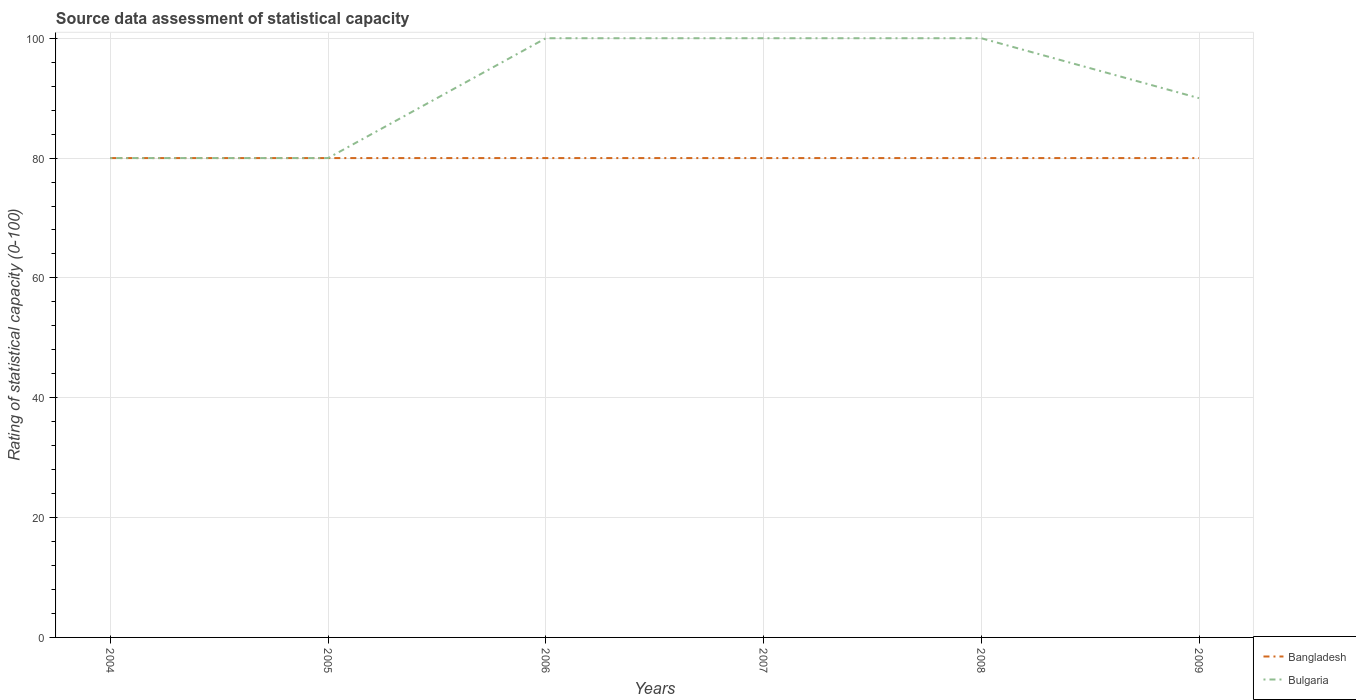Does the line corresponding to Bulgaria intersect with the line corresponding to Bangladesh?
Keep it short and to the point. Yes. Is the number of lines equal to the number of legend labels?
Provide a short and direct response. Yes. Across all years, what is the maximum rating of statistical capacity in Bangladesh?
Offer a very short reply. 80. What is the total rating of statistical capacity in Bangladesh in the graph?
Ensure brevity in your answer.  0. What is the difference between the highest and the lowest rating of statistical capacity in Bangladesh?
Provide a succinct answer. 0. Is the rating of statistical capacity in Bulgaria strictly greater than the rating of statistical capacity in Bangladesh over the years?
Your answer should be very brief. No. How many lines are there?
Offer a very short reply. 2. Does the graph contain grids?
Give a very brief answer. Yes. How are the legend labels stacked?
Keep it short and to the point. Vertical. What is the title of the graph?
Offer a terse response. Source data assessment of statistical capacity. Does "Saudi Arabia" appear as one of the legend labels in the graph?
Your response must be concise. No. What is the label or title of the X-axis?
Your response must be concise. Years. What is the label or title of the Y-axis?
Keep it short and to the point. Rating of statistical capacity (0-100). What is the Rating of statistical capacity (0-100) of Bangladesh in 2004?
Offer a very short reply. 80. What is the Rating of statistical capacity (0-100) of Bulgaria in 2005?
Provide a succinct answer. 80. What is the Rating of statistical capacity (0-100) of Bangladesh in 2006?
Offer a very short reply. 80. What is the Rating of statistical capacity (0-100) in Bulgaria in 2006?
Offer a very short reply. 100. What is the Rating of statistical capacity (0-100) in Bulgaria in 2007?
Provide a succinct answer. 100. What is the Rating of statistical capacity (0-100) of Bulgaria in 2008?
Provide a succinct answer. 100. What is the Rating of statistical capacity (0-100) of Bangladesh in 2009?
Provide a short and direct response. 80. Across all years, what is the maximum Rating of statistical capacity (0-100) in Bulgaria?
Offer a very short reply. 100. What is the total Rating of statistical capacity (0-100) in Bangladesh in the graph?
Your answer should be very brief. 480. What is the total Rating of statistical capacity (0-100) of Bulgaria in the graph?
Your answer should be very brief. 550. What is the difference between the Rating of statistical capacity (0-100) of Bulgaria in 2004 and that in 2007?
Offer a very short reply. -20. What is the difference between the Rating of statistical capacity (0-100) in Bangladesh in 2004 and that in 2008?
Offer a very short reply. 0. What is the difference between the Rating of statistical capacity (0-100) in Bulgaria in 2004 and that in 2008?
Provide a succinct answer. -20. What is the difference between the Rating of statistical capacity (0-100) in Bangladesh in 2004 and that in 2009?
Your answer should be very brief. 0. What is the difference between the Rating of statistical capacity (0-100) of Bulgaria in 2004 and that in 2009?
Provide a succinct answer. -10. What is the difference between the Rating of statistical capacity (0-100) in Bangladesh in 2005 and that in 2006?
Ensure brevity in your answer.  0. What is the difference between the Rating of statistical capacity (0-100) of Bulgaria in 2005 and that in 2006?
Offer a very short reply. -20. What is the difference between the Rating of statistical capacity (0-100) in Bangladesh in 2005 and that in 2007?
Your answer should be compact. 0. What is the difference between the Rating of statistical capacity (0-100) of Bulgaria in 2005 and that in 2007?
Ensure brevity in your answer.  -20. What is the difference between the Rating of statistical capacity (0-100) of Bangladesh in 2005 and that in 2008?
Your answer should be compact. 0. What is the difference between the Rating of statistical capacity (0-100) in Bangladesh in 2005 and that in 2009?
Make the answer very short. 0. What is the difference between the Rating of statistical capacity (0-100) in Bulgaria in 2006 and that in 2007?
Make the answer very short. 0. What is the difference between the Rating of statistical capacity (0-100) in Bulgaria in 2006 and that in 2008?
Give a very brief answer. 0. What is the difference between the Rating of statistical capacity (0-100) in Bulgaria in 2007 and that in 2008?
Give a very brief answer. 0. What is the difference between the Rating of statistical capacity (0-100) of Bulgaria in 2007 and that in 2009?
Offer a terse response. 10. What is the difference between the Rating of statistical capacity (0-100) in Bangladesh in 2008 and that in 2009?
Offer a terse response. 0. What is the difference between the Rating of statistical capacity (0-100) in Bulgaria in 2008 and that in 2009?
Keep it short and to the point. 10. What is the difference between the Rating of statistical capacity (0-100) in Bangladesh in 2004 and the Rating of statistical capacity (0-100) in Bulgaria in 2005?
Your answer should be very brief. 0. What is the difference between the Rating of statistical capacity (0-100) of Bangladesh in 2004 and the Rating of statistical capacity (0-100) of Bulgaria in 2008?
Make the answer very short. -20. What is the difference between the Rating of statistical capacity (0-100) in Bangladesh in 2005 and the Rating of statistical capacity (0-100) in Bulgaria in 2007?
Keep it short and to the point. -20. What is the difference between the Rating of statistical capacity (0-100) of Bangladesh in 2005 and the Rating of statistical capacity (0-100) of Bulgaria in 2008?
Offer a very short reply. -20. What is the difference between the Rating of statistical capacity (0-100) in Bangladesh in 2006 and the Rating of statistical capacity (0-100) in Bulgaria in 2007?
Your response must be concise. -20. What is the difference between the Rating of statistical capacity (0-100) in Bangladesh in 2006 and the Rating of statistical capacity (0-100) in Bulgaria in 2008?
Your answer should be compact. -20. What is the difference between the Rating of statistical capacity (0-100) of Bangladesh in 2006 and the Rating of statistical capacity (0-100) of Bulgaria in 2009?
Provide a short and direct response. -10. What is the difference between the Rating of statistical capacity (0-100) of Bangladesh in 2007 and the Rating of statistical capacity (0-100) of Bulgaria in 2009?
Make the answer very short. -10. What is the average Rating of statistical capacity (0-100) in Bulgaria per year?
Ensure brevity in your answer.  91.67. In the year 2004, what is the difference between the Rating of statistical capacity (0-100) of Bangladesh and Rating of statistical capacity (0-100) of Bulgaria?
Provide a short and direct response. 0. In the year 2007, what is the difference between the Rating of statistical capacity (0-100) of Bangladesh and Rating of statistical capacity (0-100) of Bulgaria?
Ensure brevity in your answer.  -20. What is the ratio of the Rating of statistical capacity (0-100) in Bangladesh in 2004 to that in 2005?
Give a very brief answer. 1. What is the ratio of the Rating of statistical capacity (0-100) of Bulgaria in 2004 to that in 2005?
Your response must be concise. 1. What is the ratio of the Rating of statistical capacity (0-100) of Bulgaria in 2004 to that in 2006?
Keep it short and to the point. 0.8. What is the ratio of the Rating of statistical capacity (0-100) of Bangladesh in 2004 to that in 2008?
Offer a very short reply. 1. What is the ratio of the Rating of statistical capacity (0-100) in Bulgaria in 2004 to that in 2008?
Your response must be concise. 0.8. What is the ratio of the Rating of statistical capacity (0-100) in Bulgaria in 2004 to that in 2009?
Ensure brevity in your answer.  0.89. What is the ratio of the Rating of statistical capacity (0-100) in Bulgaria in 2005 to that in 2006?
Your answer should be very brief. 0.8. What is the ratio of the Rating of statistical capacity (0-100) in Bangladesh in 2005 to that in 2007?
Offer a very short reply. 1. What is the ratio of the Rating of statistical capacity (0-100) of Bulgaria in 2005 to that in 2007?
Provide a short and direct response. 0.8. What is the ratio of the Rating of statistical capacity (0-100) in Bangladesh in 2005 to that in 2008?
Offer a terse response. 1. What is the ratio of the Rating of statistical capacity (0-100) of Bangladesh in 2005 to that in 2009?
Offer a terse response. 1. What is the ratio of the Rating of statistical capacity (0-100) in Bangladesh in 2006 to that in 2007?
Offer a very short reply. 1. What is the ratio of the Rating of statistical capacity (0-100) in Bulgaria in 2006 to that in 2008?
Ensure brevity in your answer.  1. What is the ratio of the Rating of statistical capacity (0-100) of Bulgaria in 2007 to that in 2008?
Offer a terse response. 1. What is the ratio of the Rating of statistical capacity (0-100) in Bangladesh in 2007 to that in 2009?
Provide a succinct answer. 1. What is the ratio of the Rating of statistical capacity (0-100) in Bulgaria in 2008 to that in 2009?
Provide a succinct answer. 1.11. What is the difference between the highest and the second highest Rating of statistical capacity (0-100) of Bangladesh?
Your answer should be compact. 0. What is the difference between the highest and the second highest Rating of statistical capacity (0-100) in Bulgaria?
Make the answer very short. 0. What is the difference between the highest and the lowest Rating of statistical capacity (0-100) of Bulgaria?
Keep it short and to the point. 20. 